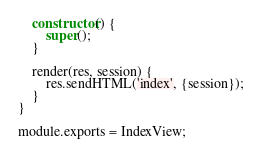<code> <loc_0><loc_0><loc_500><loc_500><_JavaScript_>    constructor() {
        super();
    }

    render(res, session) {
        res.sendHTML('index', {session});
    }
}

module.exports = IndexView;
</code> 